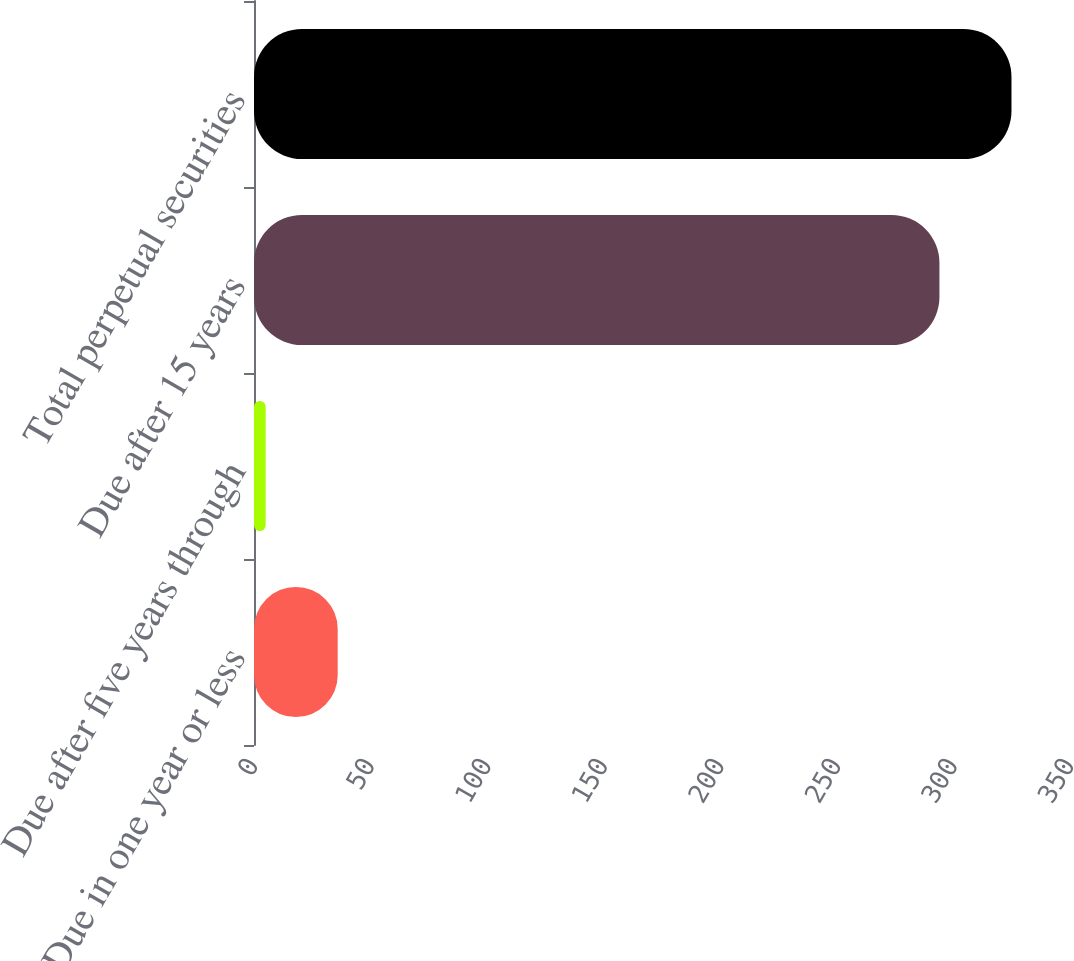Convert chart. <chart><loc_0><loc_0><loc_500><loc_500><bar_chart><fcel>Due in one year or less<fcel>Due after five years through<fcel>Due after 15 years<fcel>Total perpetual securities<nl><fcel>35.9<fcel>5<fcel>294<fcel>324.9<nl></chart> 